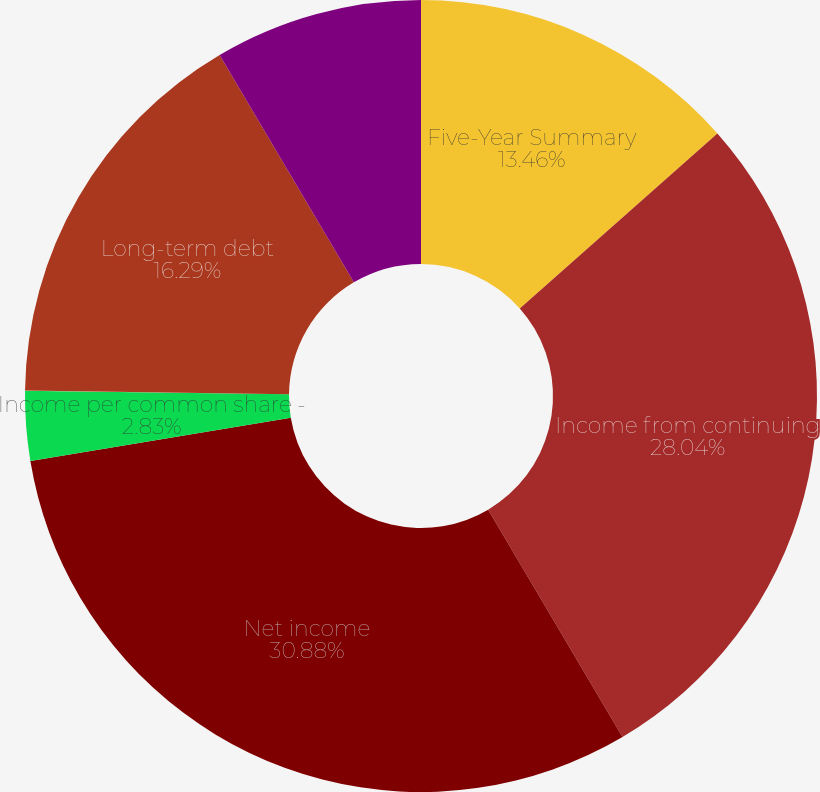Convert chart to OTSL. <chart><loc_0><loc_0><loc_500><loc_500><pie_chart><fcel>Five-Year Summary<fcel>Income from continuing<fcel>Net income<fcel>Income per common share -<fcel>Cash dividends declared per<fcel>Long-term debt<fcel>Return on invested capital (a)<nl><fcel>13.46%<fcel>28.04%<fcel>30.87%<fcel>2.83%<fcel>0.01%<fcel>16.29%<fcel>8.49%<nl></chart> 